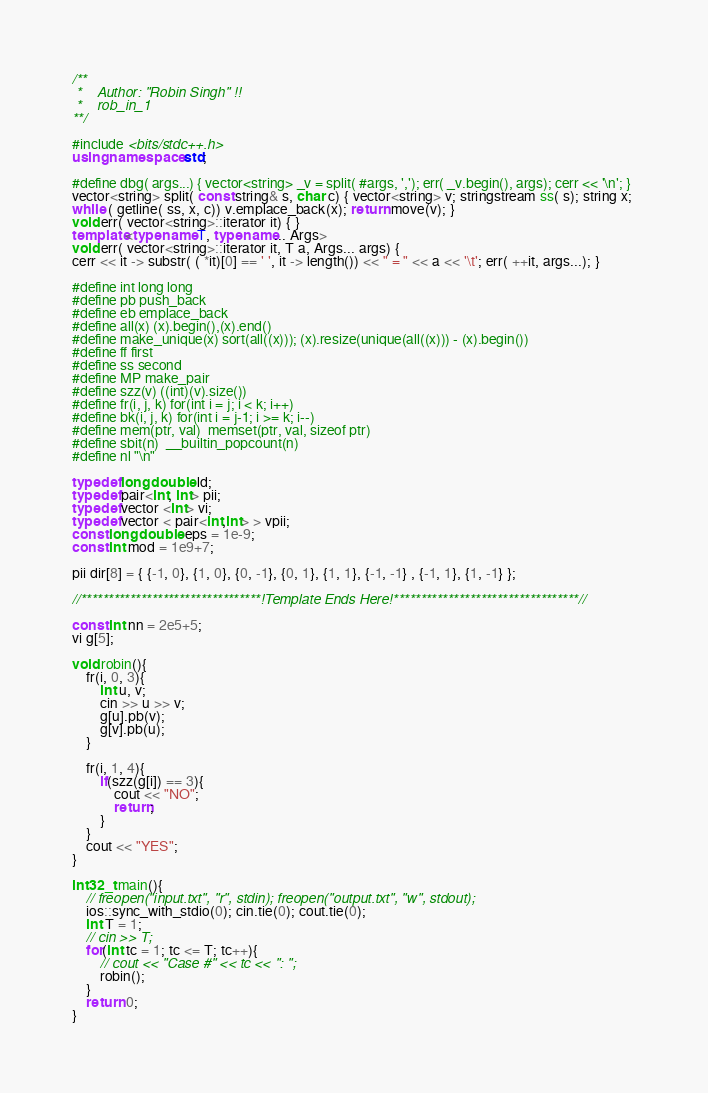Convert code to text. <code><loc_0><loc_0><loc_500><loc_500><_C++_>/**
 *    Author: "Robin Singh" !!
 *    rob_in_1
**/

#include <bits/stdc++.h>
using namespace std;

#define dbg( args...) { vector<string> _v = split( #args, ','); err( _v.begin(), args); cerr << '\n'; }
vector<string> split( const string& s, char c) { vector<string> v; stringstream ss( s); string x; 
while ( getline( ss, x, c)) v.emplace_back(x); return move(v); }
void err( vector<string>::iterator it) { } 
template<typename T, typename... Args>
void err( vector<string>::iterator it, T a, Args... args) {
cerr << it -> substr( ( *it)[0] == ' ', it -> length()) << " = " << a << '\t'; err( ++it, args...); }

#define int long long
#define pb push_back
#define eb emplace_back
#define all(x) (x).begin(),(x).end()
#define make_unique(x) sort(all((x))); (x).resize(unique(all((x))) - (x).begin())
#define ff first
#define ss second
#define MP make_pair
#define szz(v) ((int)(v).size())  
#define fr(i, j, k) for(int i = j; i < k; i++)     
#define bk(i, j, k) for(int i = j-1; i >= k; i--)
#define mem(ptr, val)  memset(ptr, val, sizeof ptr)
#define sbit(n)  __builtin_popcount(n)
#define nl "\n"

typedef long double ld;
typedef pair<int, int> pii;
typedef vector <int> vi;
typedef vector < pair<int,int> > vpii;
const long double eps = 1e-9;
const int mod = 1e9+7;

pii dir[8] = { {-1, 0}, {1, 0}, {0, -1}, {0, 1}, {1, 1}, {-1, -1} , {-1, 1}, {1, -1} };

//*********************************!Template Ends Here!**********************************//

const int nn = 2e5+5;
vi g[5];

void robin(){
	fr(i, 0, 3){
		int u, v;
		cin >> u >> v;
		g[u].pb(v);
		g[v].pb(u);
	}

	fr(i, 1, 4){
		if(szz(g[i]) == 3){
			cout << "NO";
			return;
		}
	}
	cout << "YES";
}

int32_t main(){
    // freopen("input.txt", "r", stdin); freopen("output.txt", "w", stdout);
    ios::sync_with_stdio(0); cin.tie(0); cout.tie(0);
    int T = 1;
    // cin >> T;
    for(int tc = 1; tc <= T; tc++){
    	// cout << "Case #" << tc << ": ";
    	robin();
    }
    return 0;
}</code> 